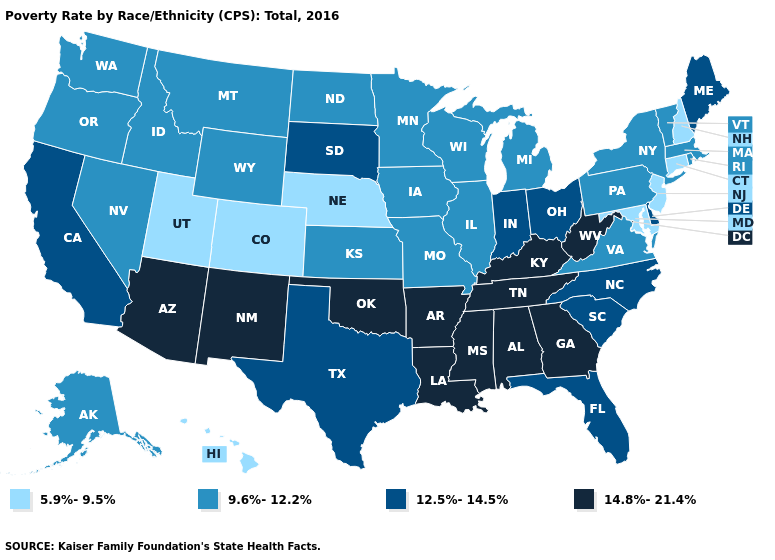Name the states that have a value in the range 14.8%-21.4%?
Write a very short answer. Alabama, Arizona, Arkansas, Georgia, Kentucky, Louisiana, Mississippi, New Mexico, Oklahoma, Tennessee, West Virginia. Does the map have missing data?
Short answer required. No. Does Georgia have the highest value in the USA?
Answer briefly. Yes. Among the states that border New Hampshire , does Maine have the lowest value?
Answer briefly. No. Name the states that have a value in the range 14.8%-21.4%?
Short answer required. Alabama, Arizona, Arkansas, Georgia, Kentucky, Louisiana, Mississippi, New Mexico, Oklahoma, Tennessee, West Virginia. Does the map have missing data?
Answer briefly. No. Does Idaho have the same value as Montana?
Short answer required. Yes. Does the map have missing data?
Write a very short answer. No. Does New Mexico have the highest value in the USA?
Give a very brief answer. Yes. What is the lowest value in states that border Rhode Island?
Keep it brief. 5.9%-9.5%. What is the value of South Dakota?
Short answer required. 12.5%-14.5%. How many symbols are there in the legend?
Quick response, please. 4. Name the states that have a value in the range 9.6%-12.2%?
Quick response, please. Alaska, Idaho, Illinois, Iowa, Kansas, Massachusetts, Michigan, Minnesota, Missouri, Montana, Nevada, New York, North Dakota, Oregon, Pennsylvania, Rhode Island, Vermont, Virginia, Washington, Wisconsin, Wyoming. 